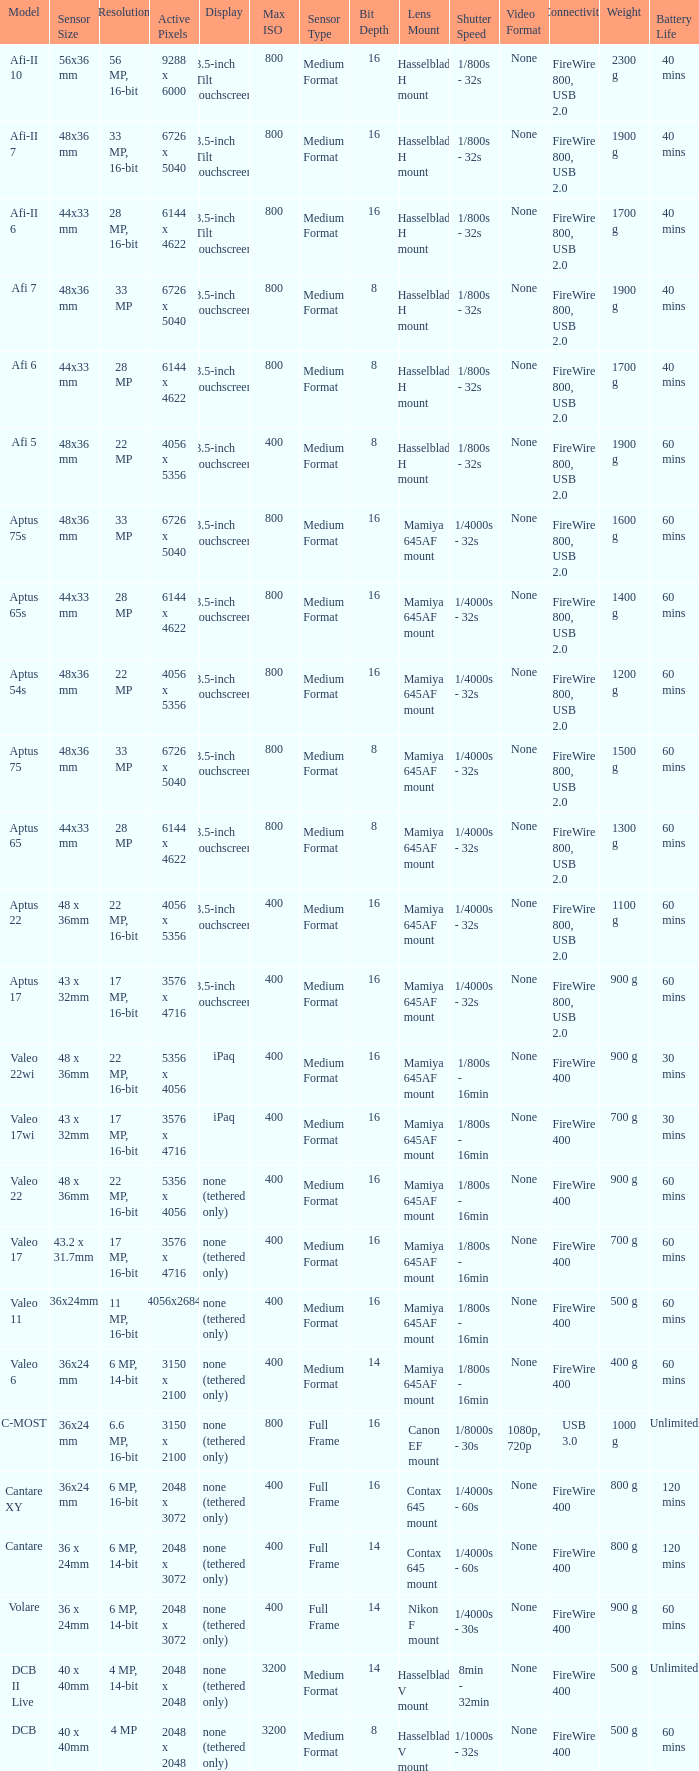What are the active pixels of the c-most model camera? 3150 x 2100. 